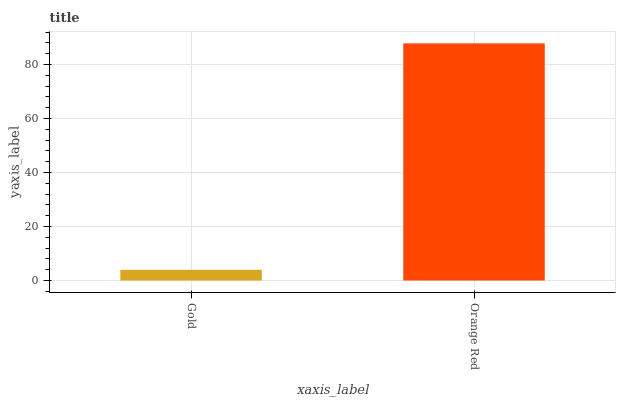Is Orange Red the minimum?
Answer yes or no. No. Is Orange Red greater than Gold?
Answer yes or no. Yes. Is Gold less than Orange Red?
Answer yes or no. Yes. Is Gold greater than Orange Red?
Answer yes or no. No. Is Orange Red less than Gold?
Answer yes or no. No. Is Orange Red the high median?
Answer yes or no. Yes. Is Gold the low median?
Answer yes or no. Yes. Is Gold the high median?
Answer yes or no. No. Is Orange Red the low median?
Answer yes or no. No. 